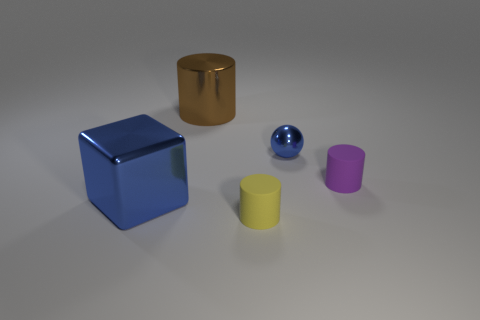Which object stands out the most and why? The large blue cube stands out prominently due to its bright color and significant size relative to the other objects. Its placement at the left also draws attention as it creates a visual anchor in the image.  Is there any indication of the texture of these objects? While the image does not permit tactile examination, visually, the objects have a smooth and reflective surface, suggesting they are made of a material like polished metal or plastic. The way the light reflects off the surfaces highlights their smooth texture. 